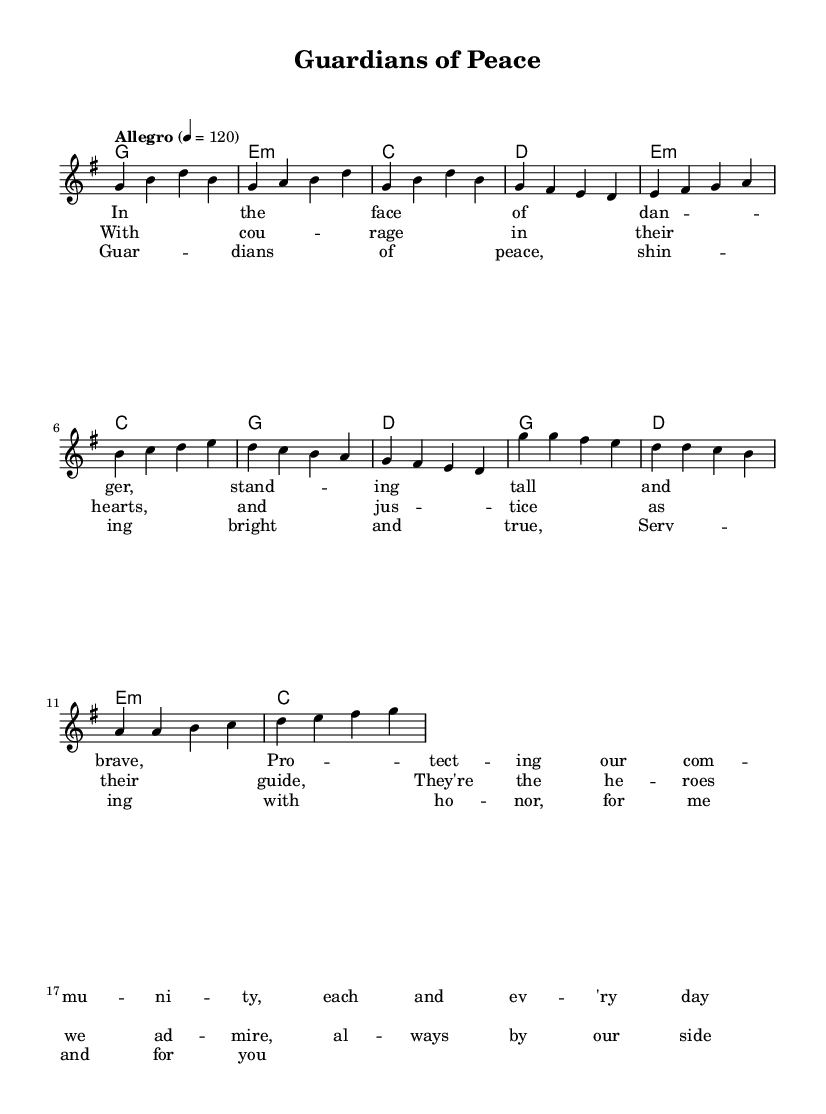What is the title of this piece? The title is located in the header section of the sheet music, clearly stated right at the beginning.
Answer: Guardians of Peace What is the key signature of this music? The key signature is indicated by the 'g' at the beginning, signifying that the piece is in G major, which has one sharp.
Answer: G major What is the time signature of this music? The time signature is shown after the key signature, marked as 4/4, meaning there are four beats per measure.
Answer: 4/4 What is the tempo marking indicated in this score? The tempo marking is located in the global section and states "Allegro" with a metronome marking of 120 beats per minute, indicating a fast and lively pace.
Answer: Allegro 4 = 120 How many sections are there in the structure of this piece? The piece has distinct sections identified as Verse, Pre-Chorus, and Chorus, which are represented with lyrics and melody. Thus, three sections are present.
Answer: 3 What do the lyrics refer to in terms of the music's theme? The lyrics celebrate bravery and heroism in service to the community, indicating their public service theme, which is common in K-Pop anthems.
Answer: Heroism and public service Which chord is used in the Chorus after the first measure? The first measure of the Chorus features the G major chord, as confirmed by analyzing the harmonies section.
Answer: G 